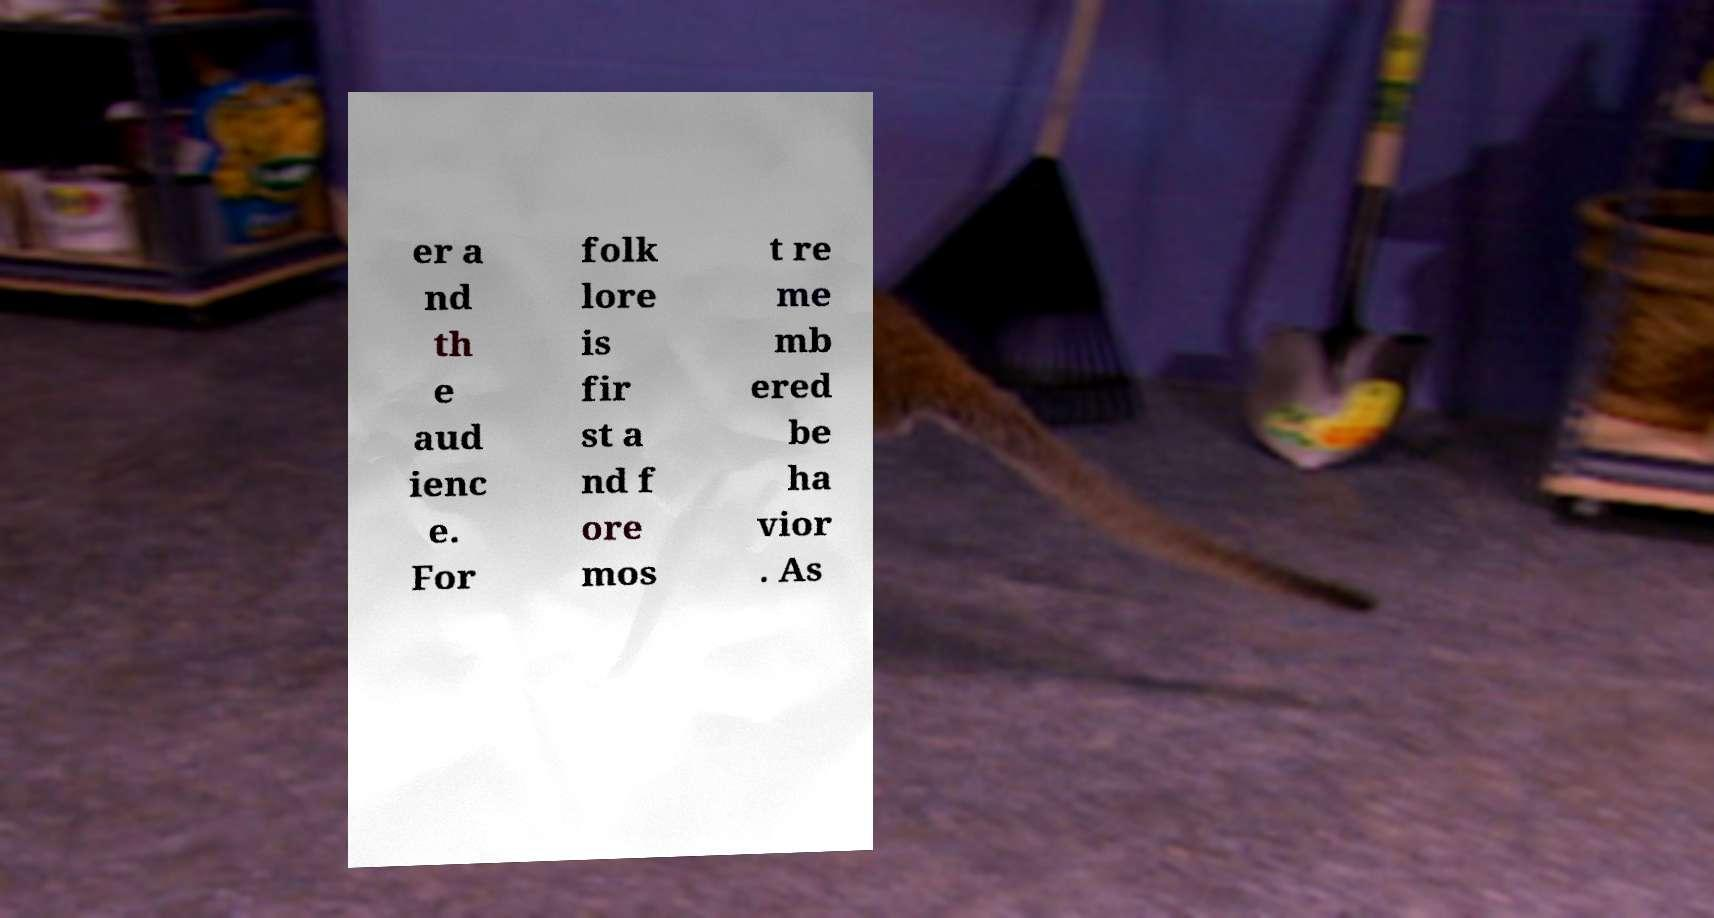Could you extract and type out the text from this image? er a nd th e aud ienc e. For folk lore is fir st a nd f ore mos t re me mb ered be ha vior . As 